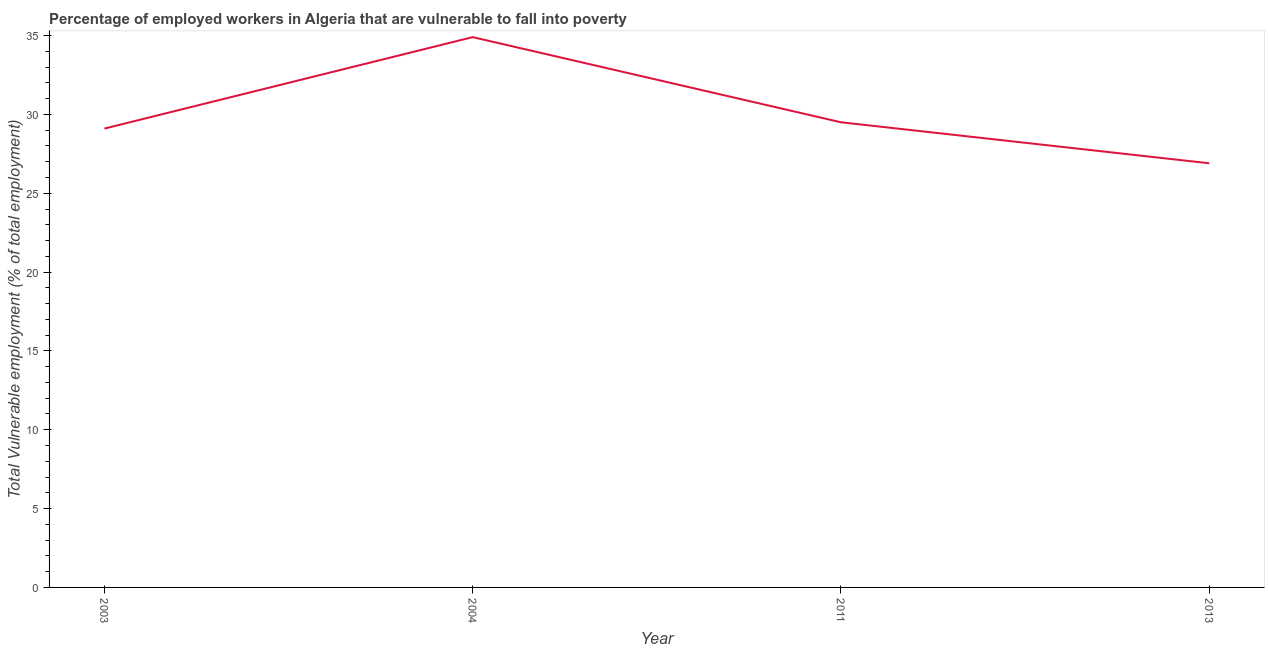What is the total vulnerable employment in 2004?
Your response must be concise. 34.9. Across all years, what is the maximum total vulnerable employment?
Keep it short and to the point. 34.9. Across all years, what is the minimum total vulnerable employment?
Your answer should be very brief. 26.9. In which year was the total vulnerable employment maximum?
Ensure brevity in your answer.  2004. What is the sum of the total vulnerable employment?
Your answer should be very brief. 120.4. What is the difference between the total vulnerable employment in 2003 and 2011?
Provide a short and direct response. -0.4. What is the average total vulnerable employment per year?
Your response must be concise. 30.1. What is the median total vulnerable employment?
Offer a terse response. 29.3. Do a majority of the years between 2011 and 2004 (inclusive) have total vulnerable employment greater than 3 %?
Your answer should be compact. No. What is the ratio of the total vulnerable employment in 2003 to that in 2013?
Your response must be concise. 1.08. Is the total vulnerable employment in 2003 less than that in 2013?
Give a very brief answer. No. What is the difference between the highest and the second highest total vulnerable employment?
Your answer should be very brief. 5.4. What is the difference between the highest and the lowest total vulnerable employment?
Ensure brevity in your answer.  8. How many lines are there?
Your answer should be very brief. 1. How many years are there in the graph?
Your answer should be compact. 4. What is the difference between two consecutive major ticks on the Y-axis?
Give a very brief answer. 5. Are the values on the major ticks of Y-axis written in scientific E-notation?
Offer a terse response. No. What is the title of the graph?
Offer a very short reply. Percentage of employed workers in Algeria that are vulnerable to fall into poverty. What is the label or title of the Y-axis?
Provide a succinct answer. Total Vulnerable employment (% of total employment). What is the Total Vulnerable employment (% of total employment) in 2003?
Give a very brief answer. 29.1. What is the Total Vulnerable employment (% of total employment) of 2004?
Give a very brief answer. 34.9. What is the Total Vulnerable employment (% of total employment) of 2011?
Ensure brevity in your answer.  29.5. What is the Total Vulnerable employment (% of total employment) in 2013?
Give a very brief answer. 26.9. What is the difference between the Total Vulnerable employment (% of total employment) in 2003 and 2011?
Ensure brevity in your answer.  -0.4. What is the difference between the Total Vulnerable employment (% of total employment) in 2003 and 2013?
Keep it short and to the point. 2.2. What is the difference between the Total Vulnerable employment (% of total employment) in 2004 and 2013?
Provide a short and direct response. 8. What is the difference between the Total Vulnerable employment (% of total employment) in 2011 and 2013?
Keep it short and to the point. 2.6. What is the ratio of the Total Vulnerable employment (% of total employment) in 2003 to that in 2004?
Keep it short and to the point. 0.83. What is the ratio of the Total Vulnerable employment (% of total employment) in 2003 to that in 2011?
Make the answer very short. 0.99. What is the ratio of the Total Vulnerable employment (% of total employment) in 2003 to that in 2013?
Ensure brevity in your answer.  1.08. What is the ratio of the Total Vulnerable employment (% of total employment) in 2004 to that in 2011?
Keep it short and to the point. 1.18. What is the ratio of the Total Vulnerable employment (% of total employment) in 2004 to that in 2013?
Your response must be concise. 1.3. What is the ratio of the Total Vulnerable employment (% of total employment) in 2011 to that in 2013?
Make the answer very short. 1.1. 